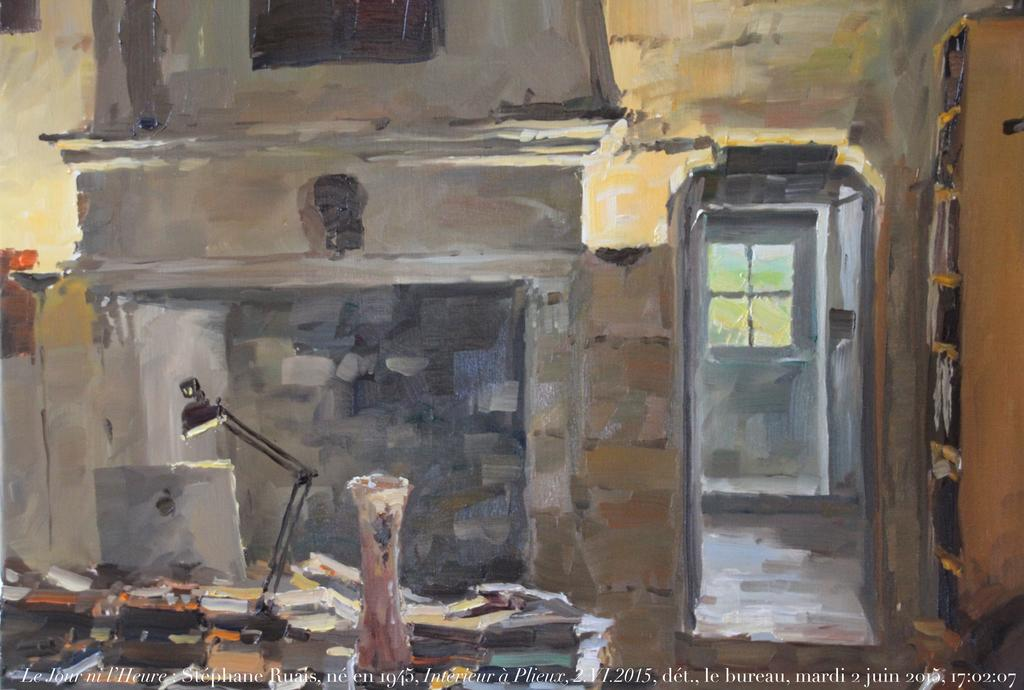<image>
Share a concise interpretation of the image provided. An impressionist painting of a room with the date 1945 visible. 